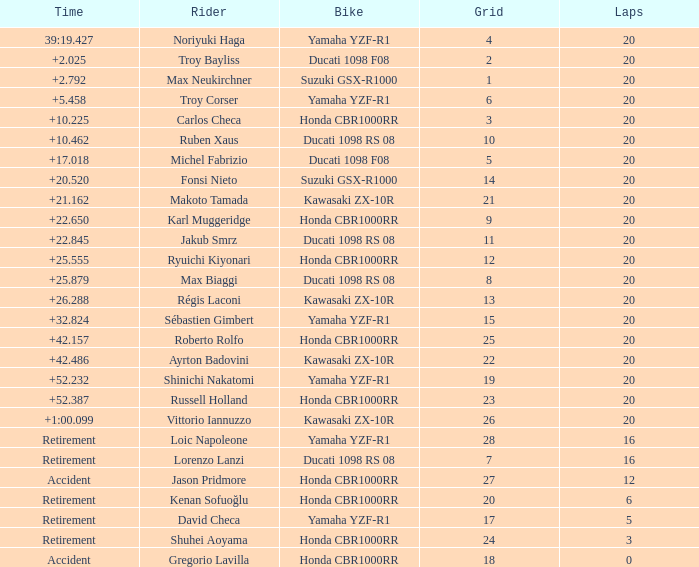What is the time of Troy Bayliss with less than 8 grids? 2.025. Can you give me this table as a dict? {'header': ['Time', 'Rider', 'Bike', 'Grid', 'Laps'], 'rows': [['39:19.427', 'Noriyuki Haga', 'Yamaha YZF-R1', '4', '20'], ['+2.025', 'Troy Bayliss', 'Ducati 1098 F08', '2', '20'], ['+2.792', 'Max Neukirchner', 'Suzuki GSX-R1000', '1', '20'], ['+5.458', 'Troy Corser', 'Yamaha YZF-R1', '6', '20'], ['+10.225', 'Carlos Checa', 'Honda CBR1000RR', '3', '20'], ['+10.462', 'Ruben Xaus', 'Ducati 1098 RS 08', '10', '20'], ['+17.018', 'Michel Fabrizio', 'Ducati 1098 F08', '5', '20'], ['+20.520', 'Fonsi Nieto', 'Suzuki GSX-R1000', '14', '20'], ['+21.162', 'Makoto Tamada', 'Kawasaki ZX-10R', '21', '20'], ['+22.650', 'Karl Muggeridge', 'Honda CBR1000RR', '9', '20'], ['+22.845', 'Jakub Smrz', 'Ducati 1098 RS 08', '11', '20'], ['+25.555', 'Ryuichi Kiyonari', 'Honda CBR1000RR', '12', '20'], ['+25.879', 'Max Biaggi', 'Ducati 1098 RS 08', '8', '20'], ['+26.288', 'Régis Laconi', 'Kawasaki ZX-10R', '13', '20'], ['+32.824', 'Sébastien Gimbert', 'Yamaha YZF-R1', '15', '20'], ['+42.157', 'Roberto Rolfo', 'Honda CBR1000RR', '25', '20'], ['+42.486', 'Ayrton Badovini', 'Kawasaki ZX-10R', '22', '20'], ['+52.232', 'Shinichi Nakatomi', 'Yamaha YZF-R1', '19', '20'], ['+52.387', 'Russell Holland', 'Honda CBR1000RR', '23', '20'], ['+1:00.099', 'Vittorio Iannuzzo', 'Kawasaki ZX-10R', '26', '20'], ['Retirement', 'Loic Napoleone', 'Yamaha YZF-R1', '28', '16'], ['Retirement', 'Lorenzo Lanzi', 'Ducati 1098 RS 08', '7', '16'], ['Accident', 'Jason Pridmore', 'Honda CBR1000RR', '27', '12'], ['Retirement', 'Kenan Sofuoğlu', 'Honda CBR1000RR', '20', '6'], ['Retirement', 'David Checa', 'Yamaha YZF-R1', '17', '5'], ['Retirement', 'Shuhei Aoyama', 'Honda CBR1000RR', '24', '3'], ['Accident', 'Gregorio Lavilla', 'Honda CBR1000RR', '18', '0']]} 